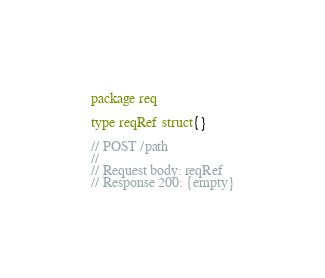<code> <loc_0><loc_0><loc_500><loc_500><_Go_>package req

type reqRef struct{}

// POST /path
//
// Request body: reqRef
// Response 200: {empty}
</code> 